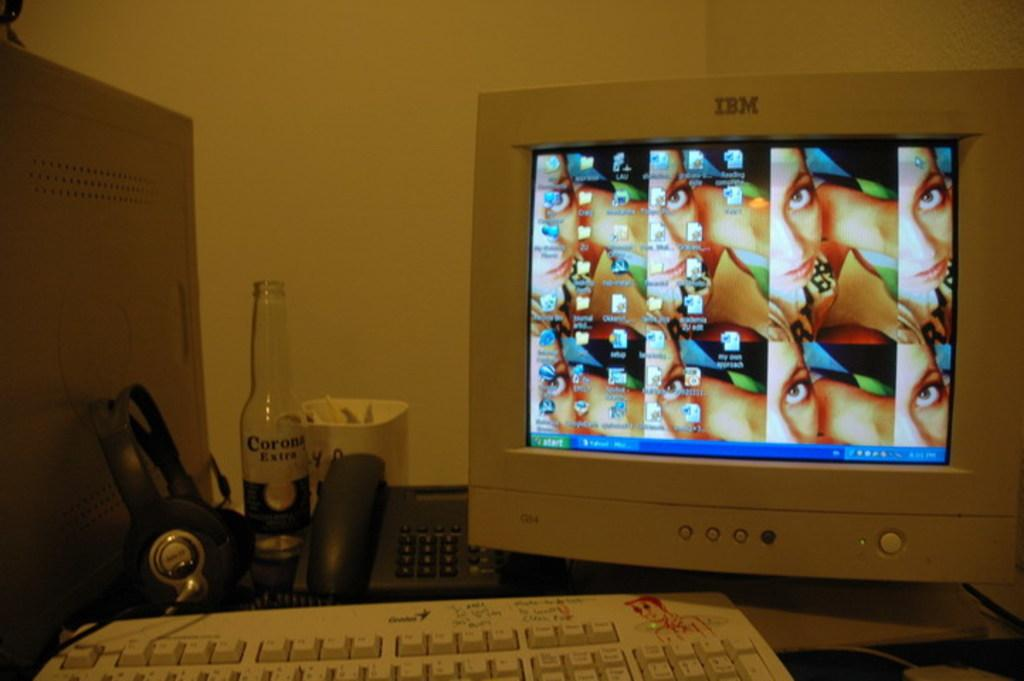<image>
Provide a brief description of the given image. a computer that is labeled 'ibm' on it and the screen that shows the start button on it 